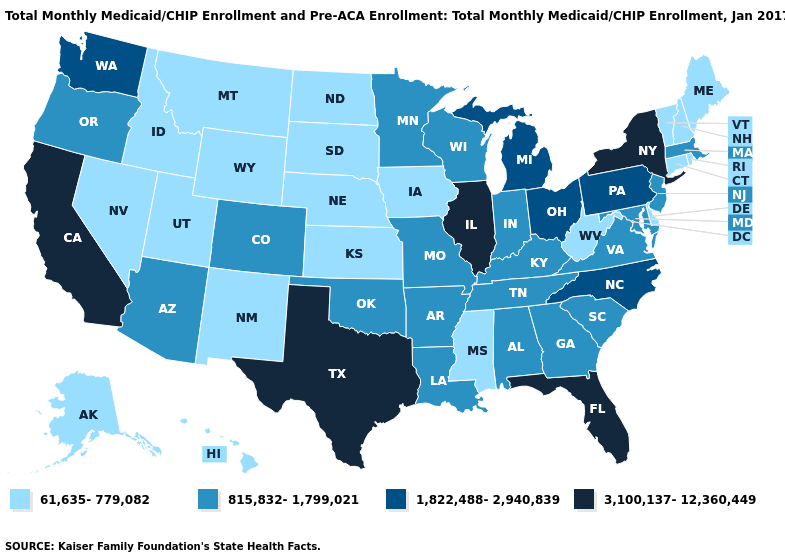What is the highest value in states that border Maine?
Keep it brief. 61,635-779,082. What is the value of Indiana?
Answer briefly. 815,832-1,799,021. Does Kansas have the same value as Virginia?
Answer briefly. No. How many symbols are there in the legend?
Answer briefly. 4. Which states hav the highest value in the MidWest?
Write a very short answer. Illinois. What is the value of Oklahoma?
Be succinct. 815,832-1,799,021. Does Nevada have the highest value in the West?
Keep it brief. No. Name the states that have a value in the range 1,822,488-2,940,839?
Answer briefly. Michigan, North Carolina, Ohio, Pennsylvania, Washington. Does Tennessee have a higher value than Texas?
Write a very short answer. No. Among the states that border Oregon , which have the lowest value?
Keep it brief. Idaho, Nevada. Does the first symbol in the legend represent the smallest category?
Write a very short answer. Yes. Does Georgia have a lower value than New Hampshire?
Give a very brief answer. No. Does Indiana have a lower value than Pennsylvania?
Give a very brief answer. Yes. What is the value of Montana?
Be succinct. 61,635-779,082. Among the states that border New Jersey , does Pennsylvania have the highest value?
Write a very short answer. No. 